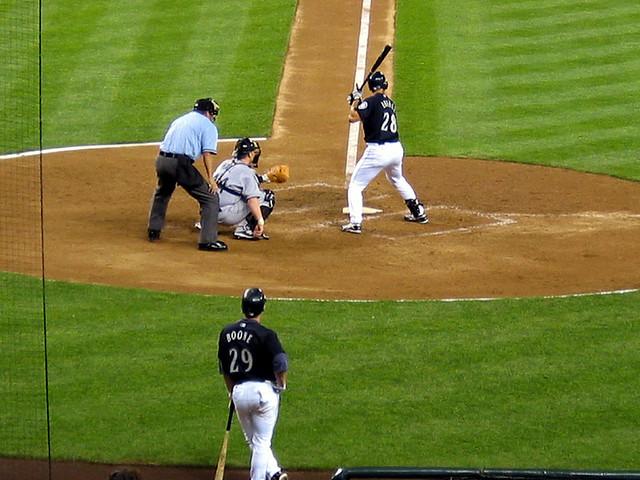Is the player in the gray uniform running?
Concise answer only. No. What does the white stripe on the ground indicate?
Give a very brief answer. Baseline. Who is standing behind the catcher?
Concise answer only. Umpire. How many players are there?
Quick response, please. 3. Is this a professional game?
Answer briefly. Yes. 